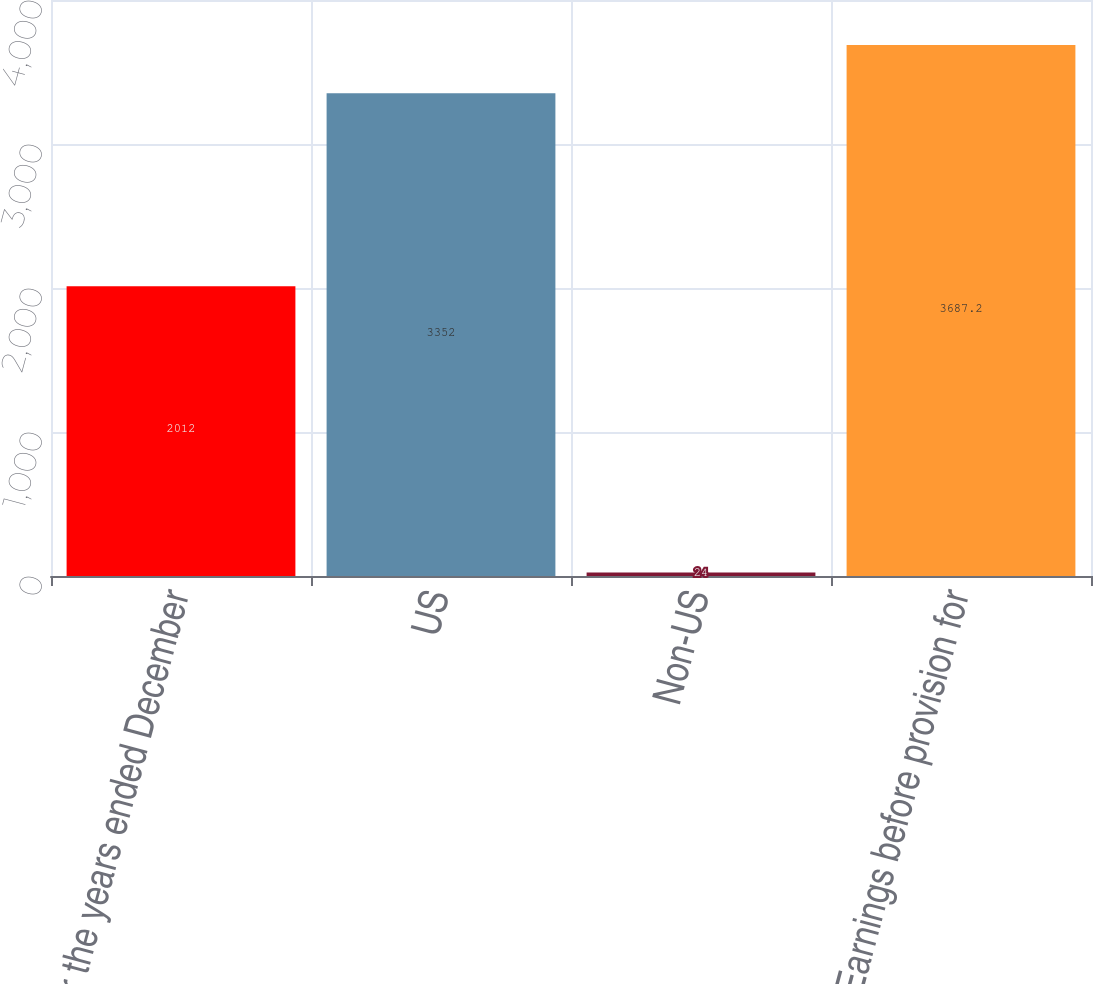<chart> <loc_0><loc_0><loc_500><loc_500><bar_chart><fcel>For the years ended December<fcel>US<fcel>Non-US<fcel>Earnings before provision for<nl><fcel>2012<fcel>3352<fcel>24<fcel>3687.2<nl></chart> 